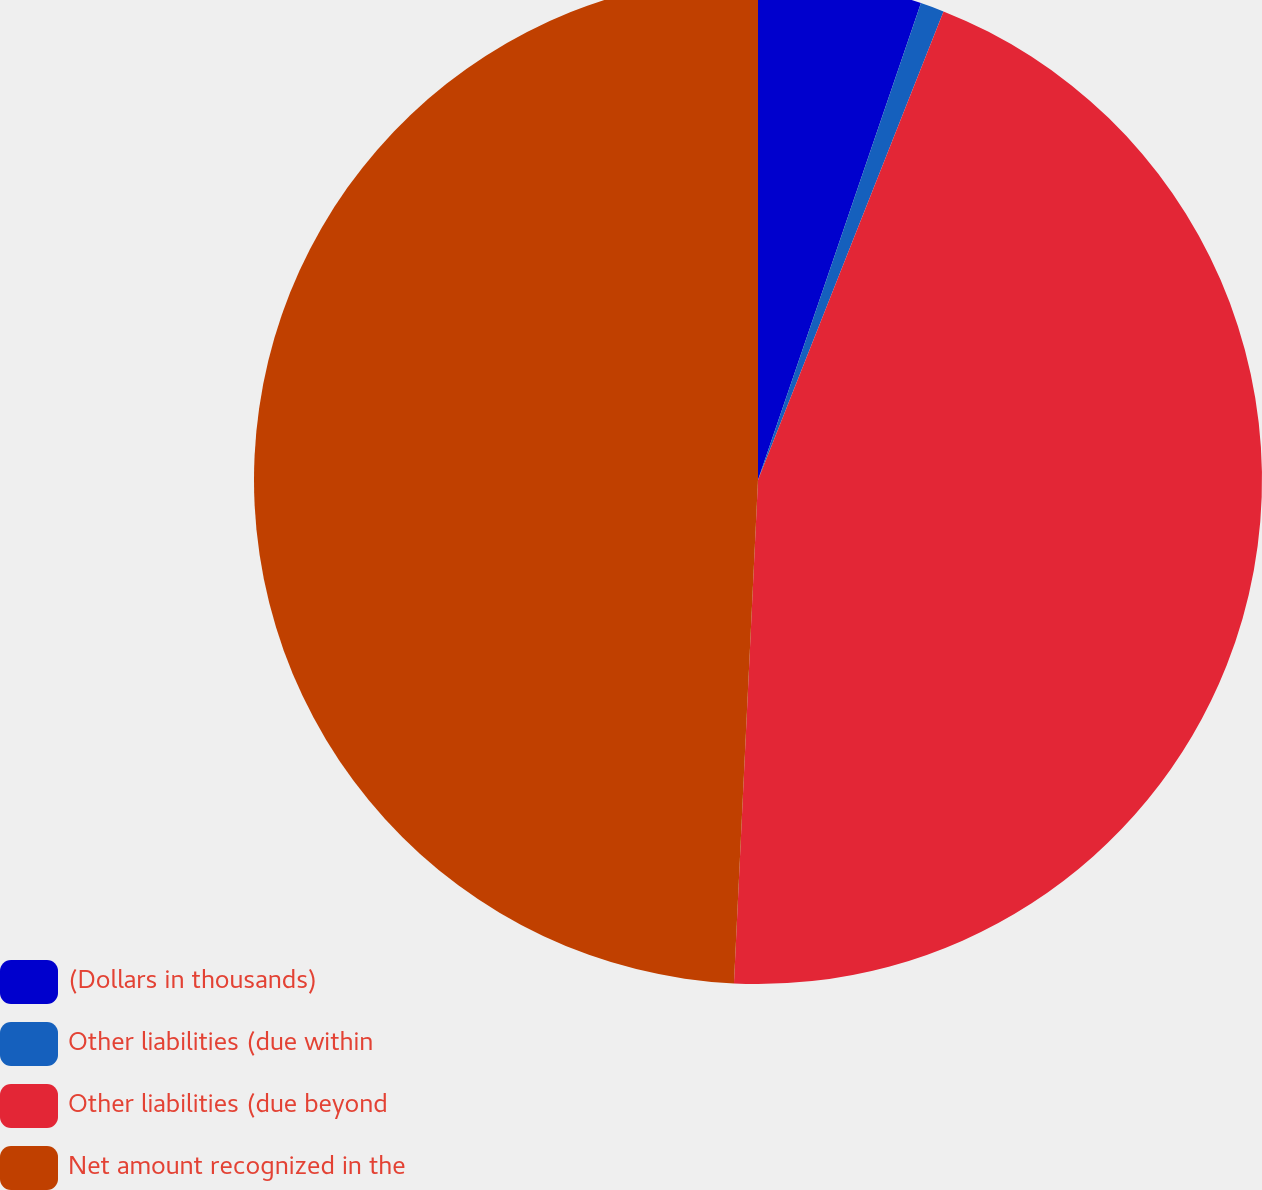Convert chart to OTSL. <chart><loc_0><loc_0><loc_500><loc_500><pie_chart><fcel>(Dollars in thousands)<fcel>Other liabilities (due within<fcel>Other liabilities (due beyond<fcel>Net amount recognized in the<nl><fcel>5.24%<fcel>0.76%<fcel>44.76%<fcel>49.24%<nl></chart> 